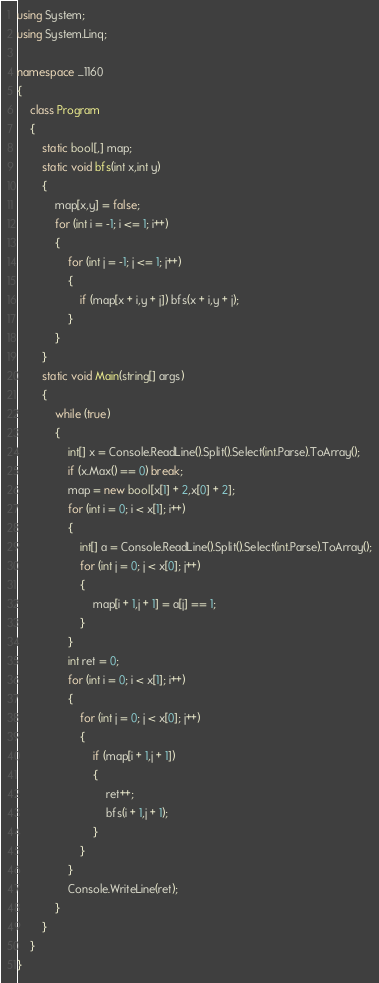Convert code to text. <code><loc_0><loc_0><loc_500><loc_500><_C#_>using System;
using System.Linq;

namespace _1160
{
    class Program
    {
        static bool[,] map;
        static void bfs(int x,int y)
        {
            map[x,y] = false;
            for (int i = -1; i <= 1; i++)
            {
                for (int j = -1; j <= 1; j++)
                {
                    if (map[x + i,y + j]) bfs(x + i,y + j);
                }
            }
        }
        static void Main(string[] args)
        {
            while (true)
            {
                int[] x = Console.ReadLine().Split().Select(int.Parse).ToArray();
                if (x.Max() == 0) break;
                map = new bool[x[1] + 2,x[0] + 2];
                for (int i = 0; i < x[1]; i++)
                {
                    int[] a = Console.ReadLine().Split().Select(int.Parse).ToArray();
                    for (int j = 0; j < x[0]; j++)
                    {
                        map[i + 1,j + 1] = a[j] == 1;
                    }
                }
                int ret = 0;
                for (int i = 0; i < x[1]; i++)
                {
                    for (int j = 0; j < x[0]; j++)
                    {
                        if (map[i + 1,j + 1])
                        {
                            ret++;
                            bfs(i + 1,j + 1);
                        }
                    }
                }
                Console.WriteLine(ret);
            }
        }
    }
}
</code> 